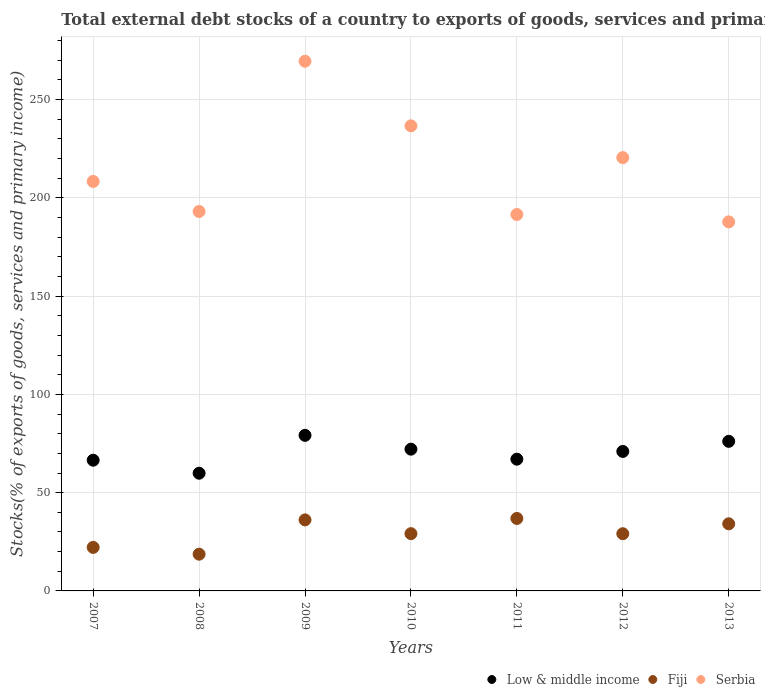Is the number of dotlines equal to the number of legend labels?
Keep it short and to the point. Yes. What is the total debt stocks in Serbia in 2009?
Give a very brief answer. 269.55. Across all years, what is the maximum total debt stocks in Fiji?
Keep it short and to the point. 36.88. Across all years, what is the minimum total debt stocks in Fiji?
Make the answer very short. 18.69. In which year was the total debt stocks in Fiji maximum?
Make the answer very short. 2011. In which year was the total debt stocks in Low & middle income minimum?
Give a very brief answer. 2008. What is the total total debt stocks in Serbia in the graph?
Your answer should be compact. 1507.55. What is the difference between the total debt stocks in Fiji in 2010 and that in 2011?
Ensure brevity in your answer.  -7.74. What is the difference between the total debt stocks in Low & middle income in 2013 and the total debt stocks in Serbia in 2009?
Give a very brief answer. -193.43. What is the average total debt stocks in Low & middle income per year?
Keep it short and to the point. 70.27. In the year 2010, what is the difference between the total debt stocks in Low & middle income and total debt stocks in Serbia?
Your response must be concise. -164.53. In how many years, is the total debt stocks in Serbia greater than 220 %?
Your response must be concise. 3. What is the ratio of the total debt stocks in Low & middle income in 2007 to that in 2008?
Your answer should be compact. 1.11. Is the total debt stocks in Low & middle income in 2007 less than that in 2012?
Keep it short and to the point. Yes. What is the difference between the highest and the second highest total debt stocks in Fiji?
Your response must be concise. 0.74. What is the difference between the highest and the lowest total debt stocks in Low & middle income?
Give a very brief answer. 19.28. Does the total debt stocks in Low & middle income monotonically increase over the years?
Ensure brevity in your answer.  No. How many dotlines are there?
Provide a short and direct response. 3. How are the legend labels stacked?
Keep it short and to the point. Horizontal. What is the title of the graph?
Your response must be concise. Total external debt stocks of a country to exports of goods, services and primary income. What is the label or title of the Y-axis?
Your response must be concise. Stocks(% of exports of goods, services and primary income). What is the Stocks(% of exports of goods, services and primary income) in Low & middle income in 2007?
Your answer should be very brief. 66.53. What is the Stocks(% of exports of goods, services and primary income) in Fiji in 2007?
Make the answer very short. 22.15. What is the Stocks(% of exports of goods, services and primary income) in Serbia in 2007?
Offer a terse response. 208.38. What is the Stocks(% of exports of goods, services and primary income) in Low & middle income in 2008?
Your response must be concise. 59.89. What is the Stocks(% of exports of goods, services and primary income) in Fiji in 2008?
Offer a very short reply. 18.69. What is the Stocks(% of exports of goods, services and primary income) of Serbia in 2008?
Provide a short and direct response. 193.09. What is the Stocks(% of exports of goods, services and primary income) in Low & middle income in 2009?
Make the answer very short. 79.18. What is the Stocks(% of exports of goods, services and primary income) of Fiji in 2009?
Your answer should be compact. 36.14. What is the Stocks(% of exports of goods, services and primary income) of Serbia in 2009?
Give a very brief answer. 269.55. What is the Stocks(% of exports of goods, services and primary income) in Low & middle income in 2010?
Your answer should be compact. 72.14. What is the Stocks(% of exports of goods, services and primary income) in Fiji in 2010?
Give a very brief answer. 29.14. What is the Stocks(% of exports of goods, services and primary income) in Serbia in 2010?
Your answer should be compact. 236.67. What is the Stocks(% of exports of goods, services and primary income) in Low & middle income in 2011?
Ensure brevity in your answer.  67.04. What is the Stocks(% of exports of goods, services and primary income) of Fiji in 2011?
Offer a very short reply. 36.88. What is the Stocks(% of exports of goods, services and primary income) in Serbia in 2011?
Provide a succinct answer. 191.56. What is the Stocks(% of exports of goods, services and primary income) of Low & middle income in 2012?
Offer a terse response. 70.98. What is the Stocks(% of exports of goods, services and primary income) in Fiji in 2012?
Provide a succinct answer. 29.1. What is the Stocks(% of exports of goods, services and primary income) in Serbia in 2012?
Keep it short and to the point. 220.5. What is the Stocks(% of exports of goods, services and primary income) in Low & middle income in 2013?
Offer a very short reply. 76.12. What is the Stocks(% of exports of goods, services and primary income) in Fiji in 2013?
Ensure brevity in your answer.  34.15. What is the Stocks(% of exports of goods, services and primary income) of Serbia in 2013?
Make the answer very short. 187.8. Across all years, what is the maximum Stocks(% of exports of goods, services and primary income) of Low & middle income?
Your response must be concise. 79.18. Across all years, what is the maximum Stocks(% of exports of goods, services and primary income) of Fiji?
Your answer should be very brief. 36.88. Across all years, what is the maximum Stocks(% of exports of goods, services and primary income) in Serbia?
Your response must be concise. 269.55. Across all years, what is the minimum Stocks(% of exports of goods, services and primary income) of Low & middle income?
Your answer should be compact. 59.89. Across all years, what is the minimum Stocks(% of exports of goods, services and primary income) in Fiji?
Keep it short and to the point. 18.69. Across all years, what is the minimum Stocks(% of exports of goods, services and primary income) of Serbia?
Your response must be concise. 187.8. What is the total Stocks(% of exports of goods, services and primary income) of Low & middle income in the graph?
Your answer should be very brief. 491.88. What is the total Stocks(% of exports of goods, services and primary income) of Fiji in the graph?
Ensure brevity in your answer.  206.27. What is the total Stocks(% of exports of goods, services and primary income) of Serbia in the graph?
Your answer should be compact. 1507.55. What is the difference between the Stocks(% of exports of goods, services and primary income) in Low & middle income in 2007 and that in 2008?
Provide a succinct answer. 6.63. What is the difference between the Stocks(% of exports of goods, services and primary income) in Fiji in 2007 and that in 2008?
Provide a succinct answer. 3.46. What is the difference between the Stocks(% of exports of goods, services and primary income) of Serbia in 2007 and that in 2008?
Your answer should be compact. 15.29. What is the difference between the Stocks(% of exports of goods, services and primary income) of Low & middle income in 2007 and that in 2009?
Provide a short and direct response. -12.65. What is the difference between the Stocks(% of exports of goods, services and primary income) of Fiji in 2007 and that in 2009?
Keep it short and to the point. -13.99. What is the difference between the Stocks(% of exports of goods, services and primary income) in Serbia in 2007 and that in 2009?
Ensure brevity in your answer.  -61.17. What is the difference between the Stocks(% of exports of goods, services and primary income) in Low & middle income in 2007 and that in 2010?
Your answer should be very brief. -5.61. What is the difference between the Stocks(% of exports of goods, services and primary income) in Fiji in 2007 and that in 2010?
Your response must be concise. -6.99. What is the difference between the Stocks(% of exports of goods, services and primary income) in Serbia in 2007 and that in 2010?
Ensure brevity in your answer.  -28.29. What is the difference between the Stocks(% of exports of goods, services and primary income) in Low & middle income in 2007 and that in 2011?
Your answer should be compact. -0.52. What is the difference between the Stocks(% of exports of goods, services and primary income) in Fiji in 2007 and that in 2011?
Ensure brevity in your answer.  -14.73. What is the difference between the Stocks(% of exports of goods, services and primary income) of Serbia in 2007 and that in 2011?
Provide a short and direct response. 16.82. What is the difference between the Stocks(% of exports of goods, services and primary income) of Low & middle income in 2007 and that in 2012?
Keep it short and to the point. -4.45. What is the difference between the Stocks(% of exports of goods, services and primary income) of Fiji in 2007 and that in 2012?
Offer a terse response. -6.95. What is the difference between the Stocks(% of exports of goods, services and primary income) of Serbia in 2007 and that in 2012?
Keep it short and to the point. -12.11. What is the difference between the Stocks(% of exports of goods, services and primary income) in Low & middle income in 2007 and that in 2013?
Offer a very short reply. -9.59. What is the difference between the Stocks(% of exports of goods, services and primary income) in Fiji in 2007 and that in 2013?
Provide a succinct answer. -12. What is the difference between the Stocks(% of exports of goods, services and primary income) of Serbia in 2007 and that in 2013?
Your answer should be very brief. 20.59. What is the difference between the Stocks(% of exports of goods, services and primary income) in Low & middle income in 2008 and that in 2009?
Provide a short and direct response. -19.28. What is the difference between the Stocks(% of exports of goods, services and primary income) in Fiji in 2008 and that in 2009?
Provide a succinct answer. -17.45. What is the difference between the Stocks(% of exports of goods, services and primary income) of Serbia in 2008 and that in 2009?
Make the answer very short. -76.47. What is the difference between the Stocks(% of exports of goods, services and primary income) in Low & middle income in 2008 and that in 2010?
Offer a very short reply. -12.24. What is the difference between the Stocks(% of exports of goods, services and primary income) of Fiji in 2008 and that in 2010?
Give a very brief answer. -10.45. What is the difference between the Stocks(% of exports of goods, services and primary income) of Serbia in 2008 and that in 2010?
Your response must be concise. -43.58. What is the difference between the Stocks(% of exports of goods, services and primary income) of Low & middle income in 2008 and that in 2011?
Your answer should be very brief. -7.15. What is the difference between the Stocks(% of exports of goods, services and primary income) in Fiji in 2008 and that in 2011?
Offer a very short reply. -18.19. What is the difference between the Stocks(% of exports of goods, services and primary income) in Serbia in 2008 and that in 2011?
Your response must be concise. 1.53. What is the difference between the Stocks(% of exports of goods, services and primary income) in Low & middle income in 2008 and that in 2012?
Provide a short and direct response. -11.09. What is the difference between the Stocks(% of exports of goods, services and primary income) of Fiji in 2008 and that in 2012?
Your answer should be compact. -10.41. What is the difference between the Stocks(% of exports of goods, services and primary income) in Serbia in 2008 and that in 2012?
Your answer should be very brief. -27.41. What is the difference between the Stocks(% of exports of goods, services and primary income) in Low & middle income in 2008 and that in 2013?
Your answer should be very brief. -16.23. What is the difference between the Stocks(% of exports of goods, services and primary income) of Fiji in 2008 and that in 2013?
Your answer should be very brief. -15.46. What is the difference between the Stocks(% of exports of goods, services and primary income) of Serbia in 2008 and that in 2013?
Your answer should be compact. 5.29. What is the difference between the Stocks(% of exports of goods, services and primary income) of Low & middle income in 2009 and that in 2010?
Offer a terse response. 7.04. What is the difference between the Stocks(% of exports of goods, services and primary income) of Fiji in 2009 and that in 2010?
Offer a very short reply. 7. What is the difference between the Stocks(% of exports of goods, services and primary income) in Serbia in 2009 and that in 2010?
Make the answer very short. 32.89. What is the difference between the Stocks(% of exports of goods, services and primary income) of Low & middle income in 2009 and that in 2011?
Ensure brevity in your answer.  12.13. What is the difference between the Stocks(% of exports of goods, services and primary income) in Fiji in 2009 and that in 2011?
Ensure brevity in your answer.  -0.74. What is the difference between the Stocks(% of exports of goods, services and primary income) of Serbia in 2009 and that in 2011?
Keep it short and to the point. 77.99. What is the difference between the Stocks(% of exports of goods, services and primary income) of Low & middle income in 2009 and that in 2012?
Offer a very short reply. 8.2. What is the difference between the Stocks(% of exports of goods, services and primary income) of Fiji in 2009 and that in 2012?
Offer a terse response. 7.04. What is the difference between the Stocks(% of exports of goods, services and primary income) of Serbia in 2009 and that in 2012?
Offer a very short reply. 49.06. What is the difference between the Stocks(% of exports of goods, services and primary income) in Low & middle income in 2009 and that in 2013?
Make the answer very short. 3.06. What is the difference between the Stocks(% of exports of goods, services and primary income) in Fiji in 2009 and that in 2013?
Ensure brevity in your answer.  1.99. What is the difference between the Stocks(% of exports of goods, services and primary income) in Serbia in 2009 and that in 2013?
Provide a succinct answer. 81.76. What is the difference between the Stocks(% of exports of goods, services and primary income) of Low & middle income in 2010 and that in 2011?
Provide a succinct answer. 5.09. What is the difference between the Stocks(% of exports of goods, services and primary income) of Fiji in 2010 and that in 2011?
Your response must be concise. -7.74. What is the difference between the Stocks(% of exports of goods, services and primary income) of Serbia in 2010 and that in 2011?
Give a very brief answer. 45.11. What is the difference between the Stocks(% of exports of goods, services and primary income) of Low & middle income in 2010 and that in 2012?
Keep it short and to the point. 1.16. What is the difference between the Stocks(% of exports of goods, services and primary income) of Fiji in 2010 and that in 2012?
Ensure brevity in your answer.  0.04. What is the difference between the Stocks(% of exports of goods, services and primary income) of Serbia in 2010 and that in 2012?
Your response must be concise. 16.17. What is the difference between the Stocks(% of exports of goods, services and primary income) of Low & middle income in 2010 and that in 2013?
Provide a short and direct response. -3.98. What is the difference between the Stocks(% of exports of goods, services and primary income) of Fiji in 2010 and that in 2013?
Your answer should be very brief. -5.01. What is the difference between the Stocks(% of exports of goods, services and primary income) of Serbia in 2010 and that in 2013?
Offer a very short reply. 48.87. What is the difference between the Stocks(% of exports of goods, services and primary income) in Low & middle income in 2011 and that in 2012?
Keep it short and to the point. -3.94. What is the difference between the Stocks(% of exports of goods, services and primary income) in Fiji in 2011 and that in 2012?
Offer a terse response. 7.78. What is the difference between the Stocks(% of exports of goods, services and primary income) in Serbia in 2011 and that in 2012?
Provide a short and direct response. -28.94. What is the difference between the Stocks(% of exports of goods, services and primary income) in Low & middle income in 2011 and that in 2013?
Offer a terse response. -9.08. What is the difference between the Stocks(% of exports of goods, services and primary income) in Fiji in 2011 and that in 2013?
Provide a succinct answer. 2.73. What is the difference between the Stocks(% of exports of goods, services and primary income) of Serbia in 2011 and that in 2013?
Make the answer very short. 3.76. What is the difference between the Stocks(% of exports of goods, services and primary income) of Low & middle income in 2012 and that in 2013?
Offer a terse response. -5.14. What is the difference between the Stocks(% of exports of goods, services and primary income) in Fiji in 2012 and that in 2013?
Offer a terse response. -5.05. What is the difference between the Stocks(% of exports of goods, services and primary income) in Serbia in 2012 and that in 2013?
Provide a short and direct response. 32.7. What is the difference between the Stocks(% of exports of goods, services and primary income) in Low & middle income in 2007 and the Stocks(% of exports of goods, services and primary income) in Fiji in 2008?
Make the answer very short. 47.84. What is the difference between the Stocks(% of exports of goods, services and primary income) of Low & middle income in 2007 and the Stocks(% of exports of goods, services and primary income) of Serbia in 2008?
Keep it short and to the point. -126.56. What is the difference between the Stocks(% of exports of goods, services and primary income) of Fiji in 2007 and the Stocks(% of exports of goods, services and primary income) of Serbia in 2008?
Your answer should be compact. -170.94. What is the difference between the Stocks(% of exports of goods, services and primary income) of Low & middle income in 2007 and the Stocks(% of exports of goods, services and primary income) of Fiji in 2009?
Your response must be concise. 30.38. What is the difference between the Stocks(% of exports of goods, services and primary income) in Low & middle income in 2007 and the Stocks(% of exports of goods, services and primary income) in Serbia in 2009?
Provide a short and direct response. -203.03. What is the difference between the Stocks(% of exports of goods, services and primary income) in Fiji in 2007 and the Stocks(% of exports of goods, services and primary income) in Serbia in 2009?
Provide a short and direct response. -247.4. What is the difference between the Stocks(% of exports of goods, services and primary income) in Low & middle income in 2007 and the Stocks(% of exports of goods, services and primary income) in Fiji in 2010?
Offer a very short reply. 37.38. What is the difference between the Stocks(% of exports of goods, services and primary income) in Low & middle income in 2007 and the Stocks(% of exports of goods, services and primary income) in Serbia in 2010?
Ensure brevity in your answer.  -170.14. What is the difference between the Stocks(% of exports of goods, services and primary income) of Fiji in 2007 and the Stocks(% of exports of goods, services and primary income) of Serbia in 2010?
Provide a short and direct response. -214.51. What is the difference between the Stocks(% of exports of goods, services and primary income) in Low & middle income in 2007 and the Stocks(% of exports of goods, services and primary income) in Fiji in 2011?
Offer a very short reply. 29.65. What is the difference between the Stocks(% of exports of goods, services and primary income) of Low & middle income in 2007 and the Stocks(% of exports of goods, services and primary income) of Serbia in 2011?
Your answer should be very brief. -125.03. What is the difference between the Stocks(% of exports of goods, services and primary income) in Fiji in 2007 and the Stocks(% of exports of goods, services and primary income) in Serbia in 2011?
Give a very brief answer. -169.41. What is the difference between the Stocks(% of exports of goods, services and primary income) of Low & middle income in 2007 and the Stocks(% of exports of goods, services and primary income) of Fiji in 2012?
Ensure brevity in your answer.  37.42. What is the difference between the Stocks(% of exports of goods, services and primary income) in Low & middle income in 2007 and the Stocks(% of exports of goods, services and primary income) in Serbia in 2012?
Provide a short and direct response. -153.97. What is the difference between the Stocks(% of exports of goods, services and primary income) of Fiji in 2007 and the Stocks(% of exports of goods, services and primary income) of Serbia in 2012?
Give a very brief answer. -198.34. What is the difference between the Stocks(% of exports of goods, services and primary income) of Low & middle income in 2007 and the Stocks(% of exports of goods, services and primary income) of Fiji in 2013?
Provide a succinct answer. 32.38. What is the difference between the Stocks(% of exports of goods, services and primary income) in Low & middle income in 2007 and the Stocks(% of exports of goods, services and primary income) in Serbia in 2013?
Your answer should be compact. -121.27. What is the difference between the Stocks(% of exports of goods, services and primary income) of Fiji in 2007 and the Stocks(% of exports of goods, services and primary income) of Serbia in 2013?
Give a very brief answer. -165.64. What is the difference between the Stocks(% of exports of goods, services and primary income) in Low & middle income in 2008 and the Stocks(% of exports of goods, services and primary income) in Fiji in 2009?
Your response must be concise. 23.75. What is the difference between the Stocks(% of exports of goods, services and primary income) of Low & middle income in 2008 and the Stocks(% of exports of goods, services and primary income) of Serbia in 2009?
Give a very brief answer. -209.66. What is the difference between the Stocks(% of exports of goods, services and primary income) in Fiji in 2008 and the Stocks(% of exports of goods, services and primary income) in Serbia in 2009?
Make the answer very short. -250.86. What is the difference between the Stocks(% of exports of goods, services and primary income) of Low & middle income in 2008 and the Stocks(% of exports of goods, services and primary income) of Fiji in 2010?
Keep it short and to the point. 30.75. What is the difference between the Stocks(% of exports of goods, services and primary income) of Low & middle income in 2008 and the Stocks(% of exports of goods, services and primary income) of Serbia in 2010?
Provide a short and direct response. -176.77. What is the difference between the Stocks(% of exports of goods, services and primary income) in Fiji in 2008 and the Stocks(% of exports of goods, services and primary income) in Serbia in 2010?
Your answer should be compact. -217.98. What is the difference between the Stocks(% of exports of goods, services and primary income) in Low & middle income in 2008 and the Stocks(% of exports of goods, services and primary income) in Fiji in 2011?
Give a very brief answer. 23.01. What is the difference between the Stocks(% of exports of goods, services and primary income) of Low & middle income in 2008 and the Stocks(% of exports of goods, services and primary income) of Serbia in 2011?
Offer a very short reply. -131.67. What is the difference between the Stocks(% of exports of goods, services and primary income) in Fiji in 2008 and the Stocks(% of exports of goods, services and primary income) in Serbia in 2011?
Give a very brief answer. -172.87. What is the difference between the Stocks(% of exports of goods, services and primary income) in Low & middle income in 2008 and the Stocks(% of exports of goods, services and primary income) in Fiji in 2012?
Provide a succinct answer. 30.79. What is the difference between the Stocks(% of exports of goods, services and primary income) of Low & middle income in 2008 and the Stocks(% of exports of goods, services and primary income) of Serbia in 2012?
Offer a very short reply. -160.6. What is the difference between the Stocks(% of exports of goods, services and primary income) of Fiji in 2008 and the Stocks(% of exports of goods, services and primary income) of Serbia in 2012?
Offer a very short reply. -201.81. What is the difference between the Stocks(% of exports of goods, services and primary income) of Low & middle income in 2008 and the Stocks(% of exports of goods, services and primary income) of Fiji in 2013?
Keep it short and to the point. 25.74. What is the difference between the Stocks(% of exports of goods, services and primary income) in Low & middle income in 2008 and the Stocks(% of exports of goods, services and primary income) in Serbia in 2013?
Offer a terse response. -127.9. What is the difference between the Stocks(% of exports of goods, services and primary income) of Fiji in 2008 and the Stocks(% of exports of goods, services and primary income) of Serbia in 2013?
Offer a very short reply. -169.11. What is the difference between the Stocks(% of exports of goods, services and primary income) of Low & middle income in 2009 and the Stocks(% of exports of goods, services and primary income) of Fiji in 2010?
Make the answer very short. 50.03. What is the difference between the Stocks(% of exports of goods, services and primary income) of Low & middle income in 2009 and the Stocks(% of exports of goods, services and primary income) of Serbia in 2010?
Your answer should be compact. -157.49. What is the difference between the Stocks(% of exports of goods, services and primary income) of Fiji in 2009 and the Stocks(% of exports of goods, services and primary income) of Serbia in 2010?
Your answer should be compact. -200.52. What is the difference between the Stocks(% of exports of goods, services and primary income) of Low & middle income in 2009 and the Stocks(% of exports of goods, services and primary income) of Fiji in 2011?
Give a very brief answer. 42.3. What is the difference between the Stocks(% of exports of goods, services and primary income) in Low & middle income in 2009 and the Stocks(% of exports of goods, services and primary income) in Serbia in 2011?
Ensure brevity in your answer.  -112.38. What is the difference between the Stocks(% of exports of goods, services and primary income) in Fiji in 2009 and the Stocks(% of exports of goods, services and primary income) in Serbia in 2011?
Your answer should be compact. -155.42. What is the difference between the Stocks(% of exports of goods, services and primary income) of Low & middle income in 2009 and the Stocks(% of exports of goods, services and primary income) of Fiji in 2012?
Your answer should be very brief. 50.07. What is the difference between the Stocks(% of exports of goods, services and primary income) in Low & middle income in 2009 and the Stocks(% of exports of goods, services and primary income) in Serbia in 2012?
Ensure brevity in your answer.  -141.32. What is the difference between the Stocks(% of exports of goods, services and primary income) of Fiji in 2009 and the Stocks(% of exports of goods, services and primary income) of Serbia in 2012?
Make the answer very short. -184.35. What is the difference between the Stocks(% of exports of goods, services and primary income) in Low & middle income in 2009 and the Stocks(% of exports of goods, services and primary income) in Fiji in 2013?
Your response must be concise. 45.03. What is the difference between the Stocks(% of exports of goods, services and primary income) of Low & middle income in 2009 and the Stocks(% of exports of goods, services and primary income) of Serbia in 2013?
Offer a terse response. -108.62. What is the difference between the Stocks(% of exports of goods, services and primary income) of Fiji in 2009 and the Stocks(% of exports of goods, services and primary income) of Serbia in 2013?
Provide a succinct answer. -151.65. What is the difference between the Stocks(% of exports of goods, services and primary income) in Low & middle income in 2010 and the Stocks(% of exports of goods, services and primary income) in Fiji in 2011?
Give a very brief answer. 35.26. What is the difference between the Stocks(% of exports of goods, services and primary income) in Low & middle income in 2010 and the Stocks(% of exports of goods, services and primary income) in Serbia in 2011?
Provide a succinct answer. -119.42. What is the difference between the Stocks(% of exports of goods, services and primary income) in Fiji in 2010 and the Stocks(% of exports of goods, services and primary income) in Serbia in 2011?
Offer a very short reply. -162.42. What is the difference between the Stocks(% of exports of goods, services and primary income) of Low & middle income in 2010 and the Stocks(% of exports of goods, services and primary income) of Fiji in 2012?
Keep it short and to the point. 43.03. What is the difference between the Stocks(% of exports of goods, services and primary income) of Low & middle income in 2010 and the Stocks(% of exports of goods, services and primary income) of Serbia in 2012?
Your answer should be compact. -148.36. What is the difference between the Stocks(% of exports of goods, services and primary income) of Fiji in 2010 and the Stocks(% of exports of goods, services and primary income) of Serbia in 2012?
Offer a terse response. -191.35. What is the difference between the Stocks(% of exports of goods, services and primary income) in Low & middle income in 2010 and the Stocks(% of exports of goods, services and primary income) in Fiji in 2013?
Your response must be concise. 37.99. What is the difference between the Stocks(% of exports of goods, services and primary income) of Low & middle income in 2010 and the Stocks(% of exports of goods, services and primary income) of Serbia in 2013?
Offer a terse response. -115.66. What is the difference between the Stocks(% of exports of goods, services and primary income) in Fiji in 2010 and the Stocks(% of exports of goods, services and primary income) in Serbia in 2013?
Offer a terse response. -158.65. What is the difference between the Stocks(% of exports of goods, services and primary income) of Low & middle income in 2011 and the Stocks(% of exports of goods, services and primary income) of Fiji in 2012?
Offer a terse response. 37.94. What is the difference between the Stocks(% of exports of goods, services and primary income) of Low & middle income in 2011 and the Stocks(% of exports of goods, services and primary income) of Serbia in 2012?
Your answer should be compact. -153.45. What is the difference between the Stocks(% of exports of goods, services and primary income) of Fiji in 2011 and the Stocks(% of exports of goods, services and primary income) of Serbia in 2012?
Make the answer very short. -183.62. What is the difference between the Stocks(% of exports of goods, services and primary income) in Low & middle income in 2011 and the Stocks(% of exports of goods, services and primary income) in Fiji in 2013?
Provide a succinct answer. 32.89. What is the difference between the Stocks(% of exports of goods, services and primary income) of Low & middle income in 2011 and the Stocks(% of exports of goods, services and primary income) of Serbia in 2013?
Offer a very short reply. -120.75. What is the difference between the Stocks(% of exports of goods, services and primary income) of Fiji in 2011 and the Stocks(% of exports of goods, services and primary income) of Serbia in 2013?
Offer a terse response. -150.92. What is the difference between the Stocks(% of exports of goods, services and primary income) of Low & middle income in 2012 and the Stocks(% of exports of goods, services and primary income) of Fiji in 2013?
Your answer should be very brief. 36.83. What is the difference between the Stocks(% of exports of goods, services and primary income) in Low & middle income in 2012 and the Stocks(% of exports of goods, services and primary income) in Serbia in 2013?
Offer a terse response. -116.82. What is the difference between the Stocks(% of exports of goods, services and primary income) in Fiji in 2012 and the Stocks(% of exports of goods, services and primary income) in Serbia in 2013?
Keep it short and to the point. -158.69. What is the average Stocks(% of exports of goods, services and primary income) of Low & middle income per year?
Make the answer very short. 70.27. What is the average Stocks(% of exports of goods, services and primary income) in Fiji per year?
Offer a very short reply. 29.47. What is the average Stocks(% of exports of goods, services and primary income) of Serbia per year?
Provide a succinct answer. 215.36. In the year 2007, what is the difference between the Stocks(% of exports of goods, services and primary income) in Low & middle income and Stocks(% of exports of goods, services and primary income) in Fiji?
Make the answer very short. 44.37. In the year 2007, what is the difference between the Stocks(% of exports of goods, services and primary income) of Low & middle income and Stocks(% of exports of goods, services and primary income) of Serbia?
Your answer should be compact. -141.86. In the year 2007, what is the difference between the Stocks(% of exports of goods, services and primary income) of Fiji and Stocks(% of exports of goods, services and primary income) of Serbia?
Ensure brevity in your answer.  -186.23. In the year 2008, what is the difference between the Stocks(% of exports of goods, services and primary income) in Low & middle income and Stocks(% of exports of goods, services and primary income) in Fiji?
Provide a short and direct response. 41.2. In the year 2008, what is the difference between the Stocks(% of exports of goods, services and primary income) of Low & middle income and Stocks(% of exports of goods, services and primary income) of Serbia?
Provide a short and direct response. -133.19. In the year 2008, what is the difference between the Stocks(% of exports of goods, services and primary income) in Fiji and Stocks(% of exports of goods, services and primary income) in Serbia?
Your response must be concise. -174.4. In the year 2009, what is the difference between the Stocks(% of exports of goods, services and primary income) of Low & middle income and Stocks(% of exports of goods, services and primary income) of Fiji?
Give a very brief answer. 43.03. In the year 2009, what is the difference between the Stocks(% of exports of goods, services and primary income) in Low & middle income and Stocks(% of exports of goods, services and primary income) in Serbia?
Offer a very short reply. -190.38. In the year 2009, what is the difference between the Stocks(% of exports of goods, services and primary income) in Fiji and Stocks(% of exports of goods, services and primary income) in Serbia?
Ensure brevity in your answer.  -233.41. In the year 2010, what is the difference between the Stocks(% of exports of goods, services and primary income) of Low & middle income and Stocks(% of exports of goods, services and primary income) of Fiji?
Provide a succinct answer. 42.99. In the year 2010, what is the difference between the Stocks(% of exports of goods, services and primary income) in Low & middle income and Stocks(% of exports of goods, services and primary income) in Serbia?
Your answer should be very brief. -164.53. In the year 2010, what is the difference between the Stocks(% of exports of goods, services and primary income) in Fiji and Stocks(% of exports of goods, services and primary income) in Serbia?
Provide a succinct answer. -207.53. In the year 2011, what is the difference between the Stocks(% of exports of goods, services and primary income) of Low & middle income and Stocks(% of exports of goods, services and primary income) of Fiji?
Your answer should be very brief. 30.16. In the year 2011, what is the difference between the Stocks(% of exports of goods, services and primary income) in Low & middle income and Stocks(% of exports of goods, services and primary income) in Serbia?
Keep it short and to the point. -124.52. In the year 2011, what is the difference between the Stocks(% of exports of goods, services and primary income) of Fiji and Stocks(% of exports of goods, services and primary income) of Serbia?
Provide a succinct answer. -154.68. In the year 2012, what is the difference between the Stocks(% of exports of goods, services and primary income) in Low & middle income and Stocks(% of exports of goods, services and primary income) in Fiji?
Give a very brief answer. 41.88. In the year 2012, what is the difference between the Stocks(% of exports of goods, services and primary income) in Low & middle income and Stocks(% of exports of goods, services and primary income) in Serbia?
Your answer should be very brief. -149.52. In the year 2012, what is the difference between the Stocks(% of exports of goods, services and primary income) in Fiji and Stocks(% of exports of goods, services and primary income) in Serbia?
Provide a short and direct response. -191.39. In the year 2013, what is the difference between the Stocks(% of exports of goods, services and primary income) in Low & middle income and Stocks(% of exports of goods, services and primary income) in Fiji?
Your answer should be very brief. 41.97. In the year 2013, what is the difference between the Stocks(% of exports of goods, services and primary income) of Low & middle income and Stocks(% of exports of goods, services and primary income) of Serbia?
Provide a succinct answer. -111.68. In the year 2013, what is the difference between the Stocks(% of exports of goods, services and primary income) in Fiji and Stocks(% of exports of goods, services and primary income) in Serbia?
Ensure brevity in your answer.  -153.65. What is the ratio of the Stocks(% of exports of goods, services and primary income) in Low & middle income in 2007 to that in 2008?
Your response must be concise. 1.11. What is the ratio of the Stocks(% of exports of goods, services and primary income) in Fiji in 2007 to that in 2008?
Make the answer very short. 1.19. What is the ratio of the Stocks(% of exports of goods, services and primary income) of Serbia in 2007 to that in 2008?
Ensure brevity in your answer.  1.08. What is the ratio of the Stocks(% of exports of goods, services and primary income) of Low & middle income in 2007 to that in 2009?
Your response must be concise. 0.84. What is the ratio of the Stocks(% of exports of goods, services and primary income) in Fiji in 2007 to that in 2009?
Your answer should be very brief. 0.61. What is the ratio of the Stocks(% of exports of goods, services and primary income) of Serbia in 2007 to that in 2009?
Your response must be concise. 0.77. What is the ratio of the Stocks(% of exports of goods, services and primary income) of Low & middle income in 2007 to that in 2010?
Provide a succinct answer. 0.92. What is the ratio of the Stocks(% of exports of goods, services and primary income) of Fiji in 2007 to that in 2010?
Give a very brief answer. 0.76. What is the ratio of the Stocks(% of exports of goods, services and primary income) in Serbia in 2007 to that in 2010?
Ensure brevity in your answer.  0.88. What is the ratio of the Stocks(% of exports of goods, services and primary income) in Low & middle income in 2007 to that in 2011?
Ensure brevity in your answer.  0.99. What is the ratio of the Stocks(% of exports of goods, services and primary income) of Fiji in 2007 to that in 2011?
Your answer should be compact. 0.6. What is the ratio of the Stocks(% of exports of goods, services and primary income) of Serbia in 2007 to that in 2011?
Provide a short and direct response. 1.09. What is the ratio of the Stocks(% of exports of goods, services and primary income) of Low & middle income in 2007 to that in 2012?
Ensure brevity in your answer.  0.94. What is the ratio of the Stocks(% of exports of goods, services and primary income) in Fiji in 2007 to that in 2012?
Offer a very short reply. 0.76. What is the ratio of the Stocks(% of exports of goods, services and primary income) of Serbia in 2007 to that in 2012?
Your answer should be very brief. 0.95. What is the ratio of the Stocks(% of exports of goods, services and primary income) in Low & middle income in 2007 to that in 2013?
Give a very brief answer. 0.87. What is the ratio of the Stocks(% of exports of goods, services and primary income) in Fiji in 2007 to that in 2013?
Offer a very short reply. 0.65. What is the ratio of the Stocks(% of exports of goods, services and primary income) of Serbia in 2007 to that in 2013?
Make the answer very short. 1.11. What is the ratio of the Stocks(% of exports of goods, services and primary income) in Low & middle income in 2008 to that in 2009?
Offer a terse response. 0.76. What is the ratio of the Stocks(% of exports of goods, services and primary income) in Fiji in 2008 to that in 2009?
Your response must be concise. 0.52. What is the ratio of the Stocks(% of exports of goods, services and primary income) of Serbia in 2008 to that in 2009?
Give a very brief answer. 0.72. What is the ratio of the Stocks(% of exports of goods, services and primary income) in Low & middle income in 2008 to that in 2010?
Make the answer very short. 0.83. What is the ratio of the Stocks(% of exports of goods, services and primary income) in Fiji in 2008 to that in 2010?
Provide a succinct answer. 0.64. What is the ratio of the Stocks(% of exports of goods, services and primary income) of Serbia in 2008 to that in 2010?
Your answer should be compact. 0.82. What is the ratio of the Stocks(% of exports of goods, services and primary income) of Low & middle income in 2008 to that in 2011?
Offer a terse response. 0.89. What is the ratio of the Stocks(% of exports of goods, services and primary income) of Fiji in 2008 to that in 2011?
Make the answer very short. 0.51. What is the ratio of the Stocks(% of exports of goods, services and primary income) in Serbia in 2008 to that in 2011?
Ensure brevity in your answer.  1.01. What is the ratio of the Stocks(% of exports of goods, services and primary income) in Low & middle income in 2008 to that in 2012?
Your response must be concise. 0.84. What is the ratio of the Stocks(% of exports of goods, services and primary income) of Fiji in 2008 to that in 2012?
Ensure brevity in your answer.  0.64. What is the ratio of the Stocks(% of exports of goods, services and primary income) in Serbia in 2008 to that in 2012?
Offer a very short reply. 0.88. What is the ratio of the Stocks(% of exports of goods, services and primary income) of Low & middle income in 2008 to that in 2013?
Your response must be concise. 0.79. What is the ratio of the Stocks(% of exports of goods, services and primary income) of Fiji in 2008 to that in 2013?
Your answer should be very brief. 0.55. What is the ratio of the Stocks(% of exports of goods, services and primary income) of Serbia in 2008 to that in 2013?
Your response must be concise. 1.03. What is the ratio of the Stocks(% of exports of goods, services and primary income) of Low & middle income in 2009 to that in 2010?
Your response must be concise. 1.1. What is the ratio of the Stocks(% of exports of goods, services and primary income) of Fiji in 2009 to that in 2010?
Your answer should be compact. 1.24. What is the ratio of the Stocks(% of exports of goods, services and primary income) of Serbia in 2009 to that in 2010?
Your answer should be very brief. 1.14. What is the ratio of the Stocks(% of exports of goods, services and primary income) in Low & middle income in 2009 to that in 2011?
Ensure brevity in your answer.  1.18. What is the ratio of the Stocks(% of exports of goods, services and primary income) of Fiji in 2009 to that in 2011?
Provide a short and direct response. 0.98. What is the ratio of the Stocks(% of exports of goods, services and primary income) of Serbia in 2009 to that in 2011?
Ensure brevity in your answer.  1.41. What is the ratio of the Stocks(% of exports of goods, services and primary income) in Low & middle income in 2009 to that in 2012?
Your answer should be compact. 1.12. What is the ratio of the Stocks(% of exports of goods, services and primary income) of Fiji in 2009 to that in 2012?
Keep it short and to the point. 1.24. What is the ratio of the Stocks(% of exports of goods, services and primary income) of Serbia in 2009 to that in 2012?
Offer a very short reply. 1.22. What is the ratio of the Stocks(% of exports of goods, services and primary income) in Low & middle income in 2009 to that in 2013?
Your answer should be compact. 1.04. What is the ratio of the Stocks(% of exports of goods, services and primary income) of Fiji in 2009 to that in 2013?
Make the answer very short. 1.06. What is the ratio of the Stocks(% of exports of goods, services and primary income) of Serbia in 2009 to that in 2013?
Your response must be concise. 1.44. What is the ratio of the Stocks(% of exports of goods, services and primary income) in Low & middle income in 2010 to that in 2011?
Ensure brevity in your answer.  1.08. What is the ratio of the Stocks(% of exports of goods, services and primary income) of Fiji in 2010 to that in 2011?
Provide a succinct answer. 0.79. What is the ratio of the Stocks(% of exports of goods, services and primary income) of Serbia in 2010 to that in 2011?
Provide a short and direct response. 1.24. What is the ratio of the Stocks(% of exports of goods, services and primary income) of Low & middle income in 2010 to that in 2012?
Your answer should be very brief. 1.02. What is the ratio of the Stocks(% of exports of goods, services and primary income) of Fiji in 2010 to that in 2012?
Make the answer very short. 1. What is the ratio of the Stocks(% of exports of goods, services and primary income) in Serbia in 2010 to that in 2012?
Offer a very short reply. 1.07. What is the ratio of the Stocks(% of exports of goods, services and primary income) of Low & middle income in 2010 to that in 2013?
Your answer should be very brief. 0.95. What is the ratio of the Stocks(% of exports of goods, services and primary income) in Fiji in 2010 to that in 2013?
Keep it short and to the point. 0.85. What is the ratio of the Stocks(% of exports of goods, services and primary income) in Serbia in 2010 to that in 2013?
Give a very brief answer. 1.26. What is the ratio of the Stocks(% of exports of goods, services and primary income) in Low & middle income in 2011 to that in 2012?
Your answer should be very brief. 0.94. What is the ratio of the Stocks(% of exports of goods, services and primary income) in Fiji in 2011 to that in 2012?
Keep it short and to the point. 1.27. What is the ratio of the Stocks(% of exports of goods, services and primary income) in Serbia in 2011 to that in 2012?
Your answer should be very brief. 0.87. What is the ratio of the Stocks(% of exports of goods, services and primary income) of Low & middle income in 2011 to that in 2013?
Your response must be concise. 0.88. What is the ratio of the Stocks(% of exports of goods, services and primary income) of Fiji in 2011 to that in 2013?
Give a very brief answer. 1.08. What is the ratio of the Stocks(% of exports of goods, services and primary income) of Low & middle income in 2012 to that in 2013?
Offer a very short reply. 0.93. What is the ratio of the Stocks(% of exports of goods, services and primary income) of Fiji in 2012 to that in 2013?
Offer a terse response. 0.85. What is the ratio of the Stocks(% of exports of goods, services and primary income) in Serbia in 2012 to that in 2013?
Make the answer very short. 1.17. What is the difference between the highest and the second highest Stocks(% of exports of goods, services and primary income) of Low & middle income?
Your answer should be very brief. 3.06. What is the difference between the highest and the second highest Stocks(% of exports of goods, services and primary income) in Fiji?
Your answer should be very brief. 0.74. What is the difference between the highest and the second highest Stocks(% of exports of goods, services and primary income) of Serbia?
Offer a terse response. 32.89. What is the difference between the highest and the lowest Stocks(% of exports of goods, services and primary income) of Low & middle income?
Give a very brief answer. 19.28. What is the difference between the highest and the lowest Stocks(% of exports of goods, services and primary income) of Fiji?
Your answer should be very brief. 18.19. What is the difference between the highest and the lowest Stocks(% of exports of goods, services and primary income) of Serbia?
Your answer should be compact. 81.76. 